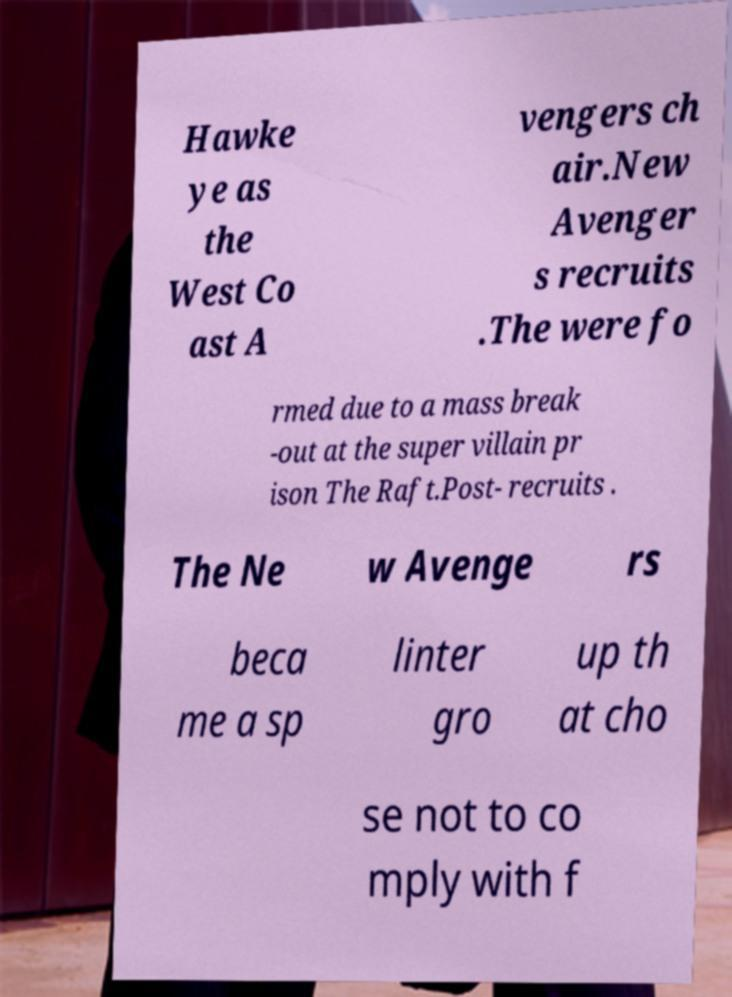Can you read and provide the text displayed in the image?This photo seems to have some interesting text. Can you extract and type it out for me? Hawke ye as the West Co ast A vengers ch air.New Avenger s recruits .The were fo rmed due to a mass break -out at the super villain pr ison The Raft.Post- recruits . The Ne w Avenge rs beca me a sp linter gro up th at cho se not to co mply with f 